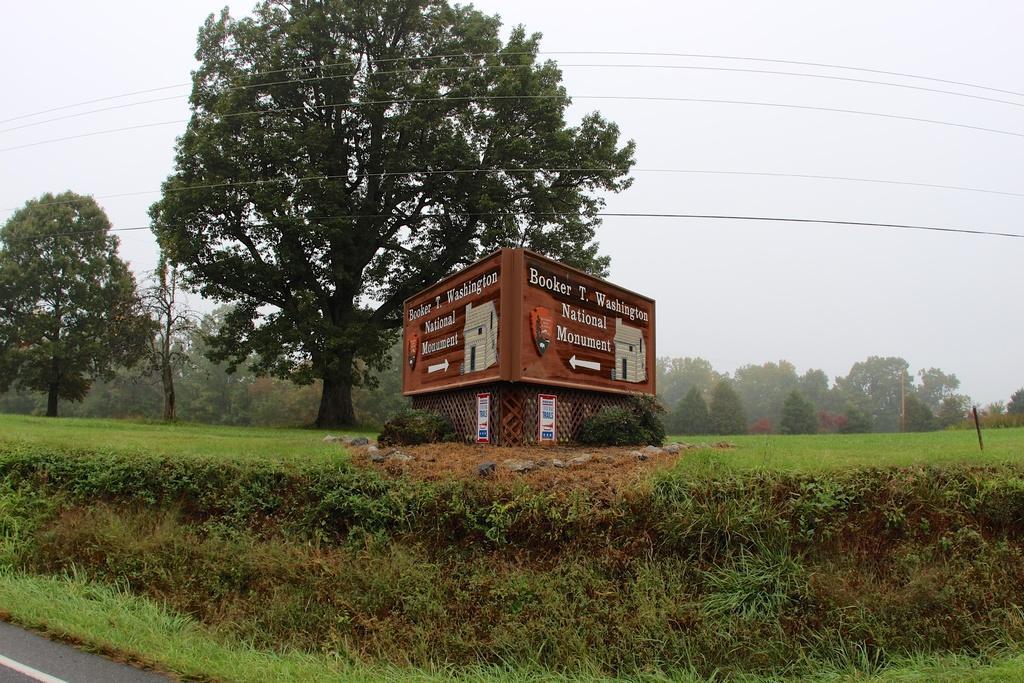Describe this image in one or two sentences. In this image I can see the road. To the side of the road I can see the grass and the boards which are in brown color. In the background there are many trees, wires and the sky. 